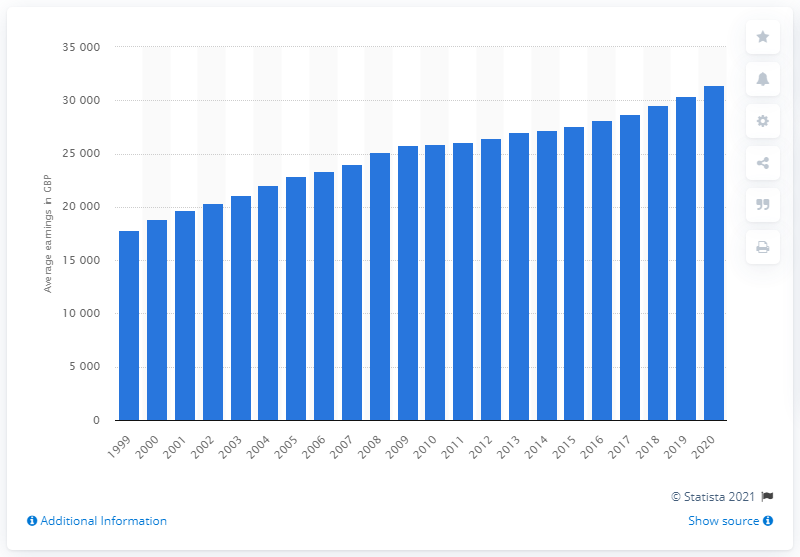Highlight a few significant elements in this photo. In 1999, the median full-time earnings were $17,803. 